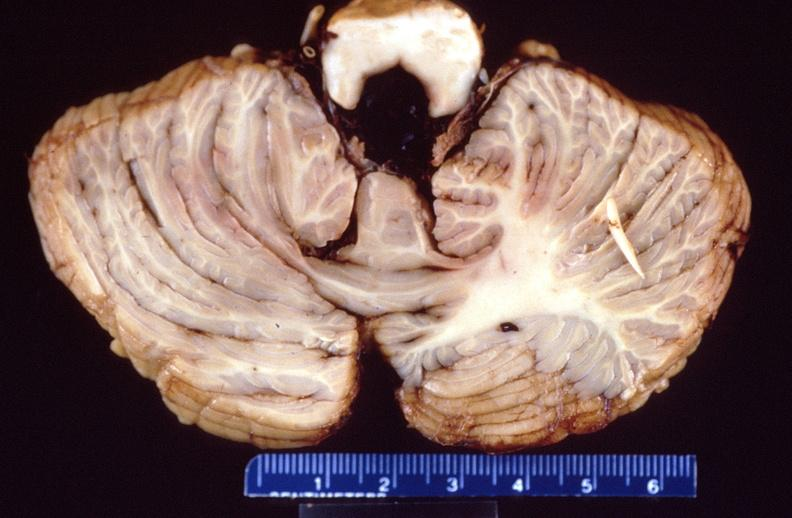what does this image show?
Answer the question using a single word or phrase. Brain 